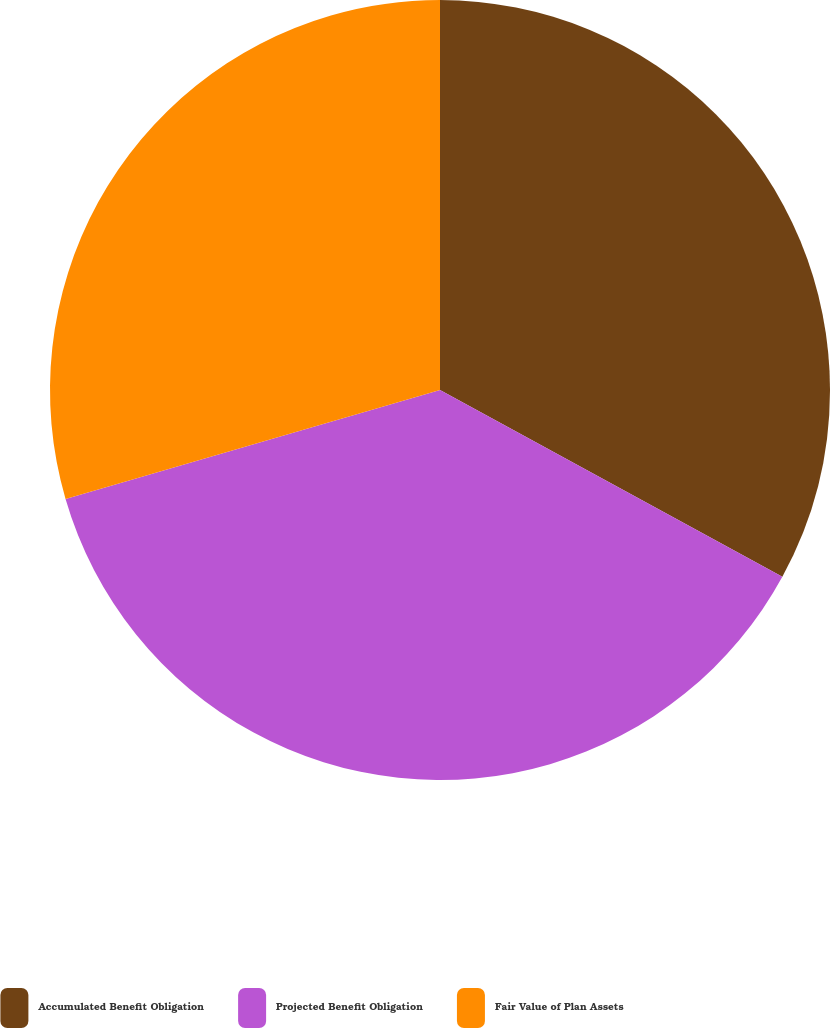<chart> <loc_0><loc_0><loc_500><loc_500><pie_chart><fcel>Accumulated Benefit Obligation<fcel>Projected Benefit Obligation<fcel>Fair Value of Plan Assets<nl><fcel>32.95%<fcel>37.54%<fcel>29.51%<nl></chart> 